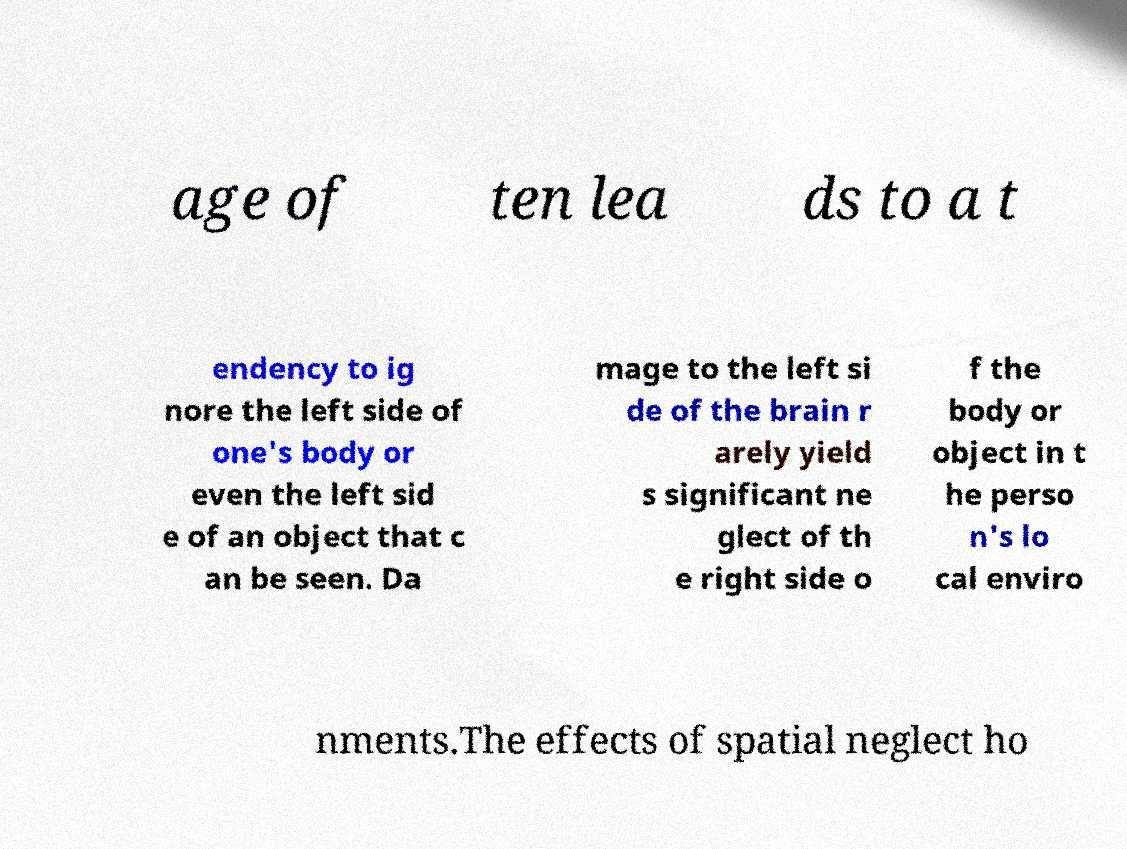Can you read and provide the text displayed in the image?This photo seems to have some interesting text. Can you extract and type it out for me? age of ten lea ds to a t endency to ig nore the left side of one's body or even the left sid e of an object that c an be seen. Da mage to the left si de of the brain r arely yield s significant ne glect of th e right side o f the body or object in t he perso n's lo cal enviro nments.The effects of spatial neglect ho 